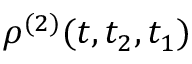<formula> <loc_0><loc_0><loc_500><loc_500>\rho ^ { ( 2 ) } ( t , t _ { 2 } , t _ { 1 } )</formula> 